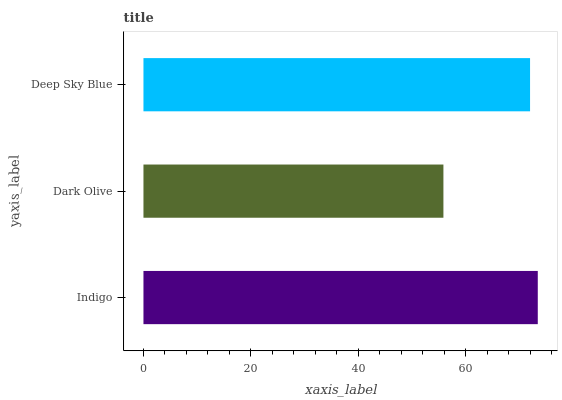Is Dark Olive the minimum?
Answer yes or no. Yes. Is Indigo the maximum?
Answer yes or no. Yes. Is Deep Sky Blue the minimum?
Answer yes or no. No. Is Deep Sky Blue the maximum?
Answer yes or no. No. Is Deep Sky Blue greater than Dark Olive?
Answer yes or no. Yes. Is Dark Olive less than Deep Sky Blue?
Answer yes or no. Yes. Is Dark Olive greater than Deep Sky Blue?
Answer yes or no. No. Is Deep Sky Blue less than Dark Olive?
Answer yes or no. No. Is Deep Sky Blue the high median?
Answer yes or no. Yes. Is Deep Sky Blue the low median?
Answer yes or no. Yes. Is Indigo the high median?
Answer yes or no. No. Is Indigo the low median?
Answer yes or no. No. 